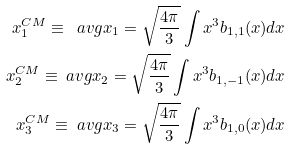Convert formula to latex. <formula><loc_0><loc_0><loc_500><loc_500>x _ { 1 } ^ { C M } \equiv \ a v g { x _ { 1 } } = \sqrt { \frac { 4 \pi } { 3 } } \int x ^ { 3 } b _ { 1 , 1 } ( x ) d x \\ x _ { 2 } ^ { C M } \equiv \ a v g { x _ { 2 } } = \sqrt { \frac { 4 \pi } { 3 } } \int x ^ { 3 } b _ { 1 , - 1 } ( x ) d x \\ x _ { 3 } ^ { C M } \equiv \ a v g { x _ { 3 } } = \sqrt { \frac { 4 \pi } { 3 } } \int x ^ { 3 } b _ { 1 , 0 } ( x ) d x</formula> 